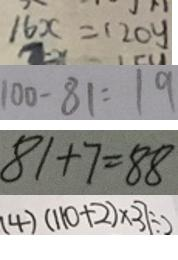Convert formula to latex. <formula><loc_0><loc_0><loc_500><loc_500>1 6 x = 1 2 0 y 
 1 0 0 - 8 1 = 1 9 
 8 1 + 7 = 8 8 
 ( 4 ) ( 1 1 0 + 2 ) \times 3 7 \div 2</formula> 